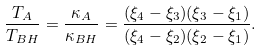<formula> <loc_0><loc_0><loc_500><loc_500>\frac { T _ { A } } { T _ { B H } } = \frac { \kappa _ { A } } { \kappa _ { B H } } = \frac { ( \xi _ { 4 } - \xi _ { 3 } ) ( \xi _ { 3 } - \xi _ { 1 } ) } { ( \xi _ { 4 } - \xi _ { 2 } ) ( \xi _ { 2 } - \xi _ { 1 } ) } .</formula> 